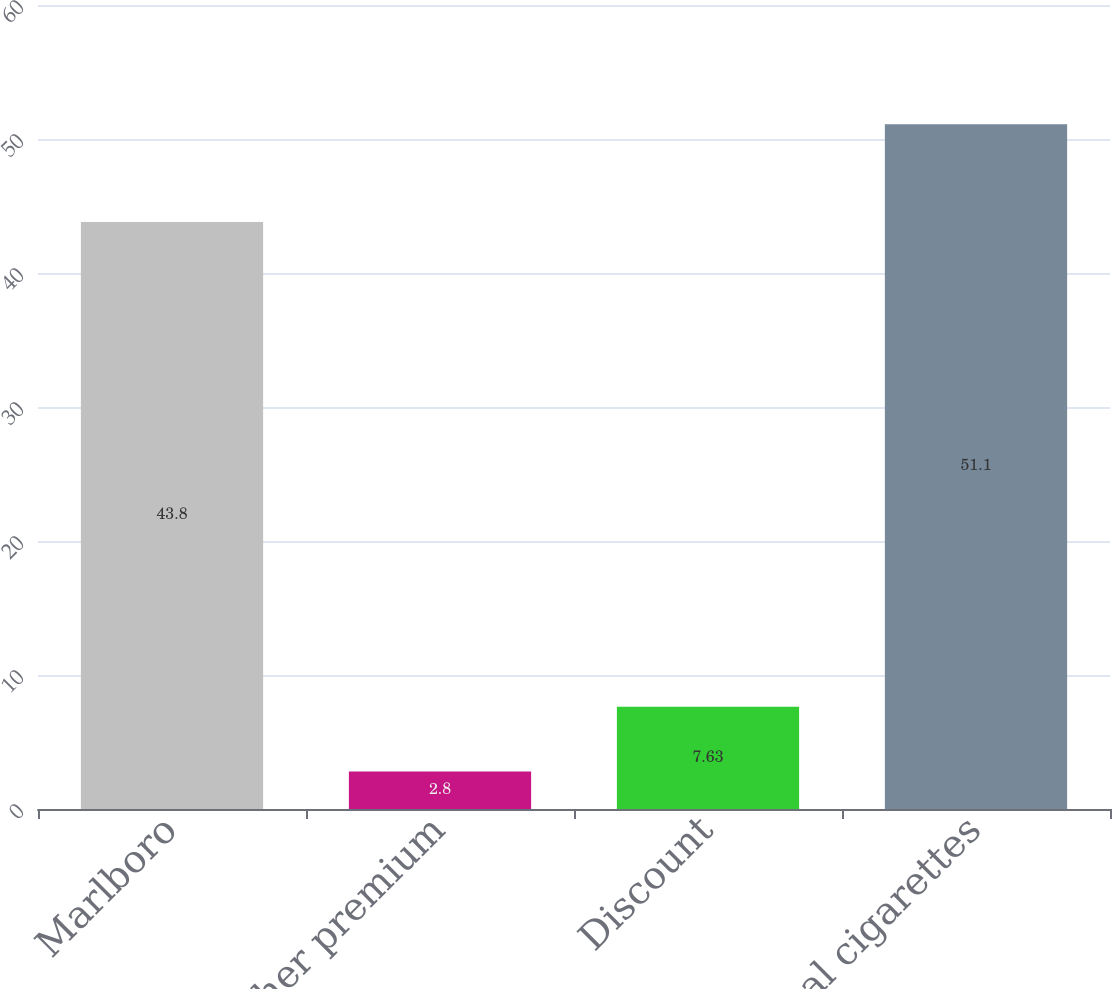Convert chart to OTSL. <chart><loc_0><loc_0><loc_500><loc_500><bar_chart><fcel>Marlboro<fcel>Other premium<fcel>Discount<fcel>Total cigarettes<nl><fcel>43.8<fcel>2.8<fcel>7.63<fcel>51.1<nl></chart> 